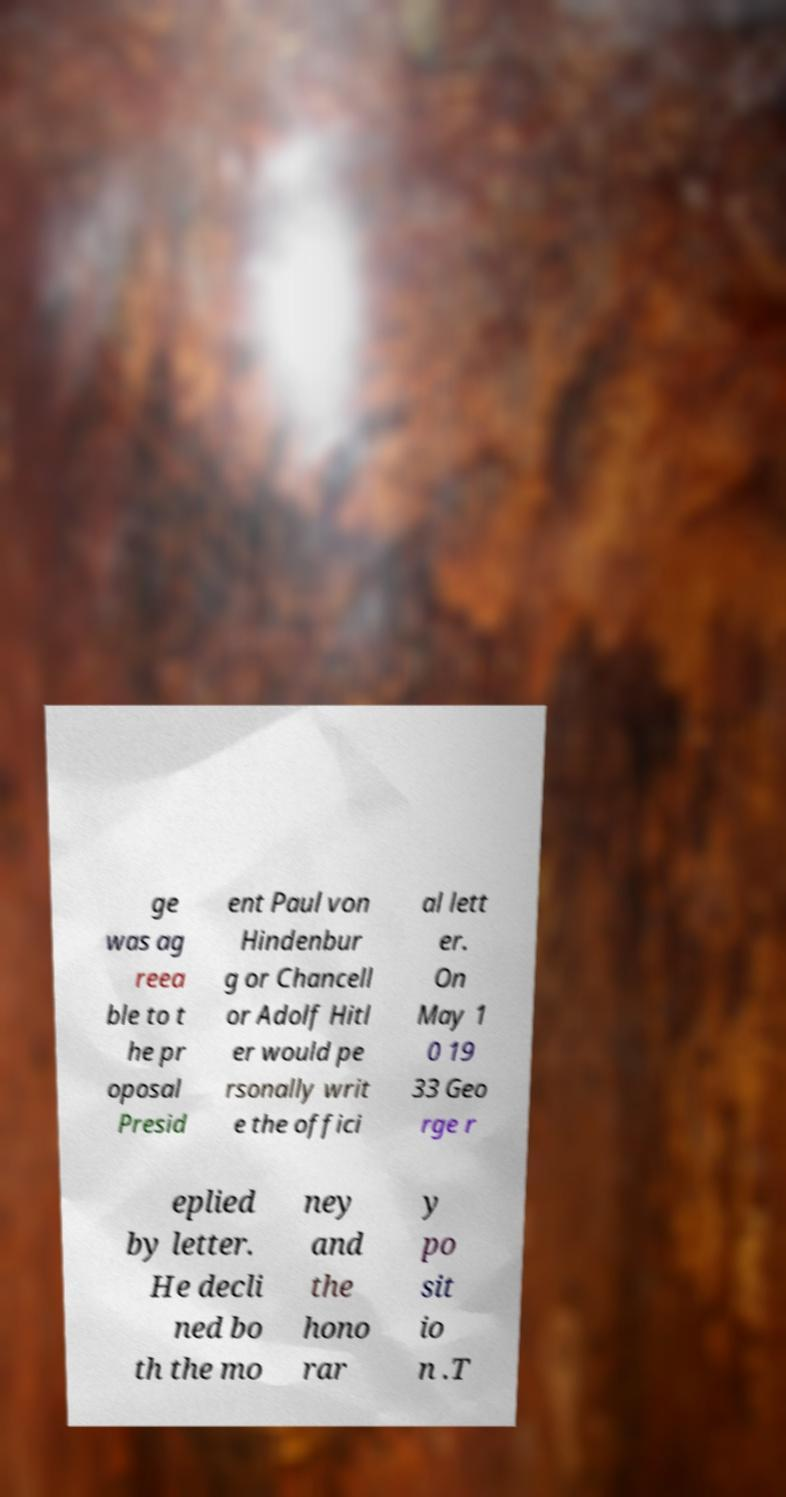Please identify and transcribe the text found in this image. ge was ag reea ble to t he pr oposal Presid ent Paul von Hindenbur g or Chancell or Adolf Hitl er would pe rsonally writ e the offici al lett er. On May 1 0 19 33 Geo rge r eplied by letter. He decli ned bo th the mo ney and the hono rar y po sit io n .T 